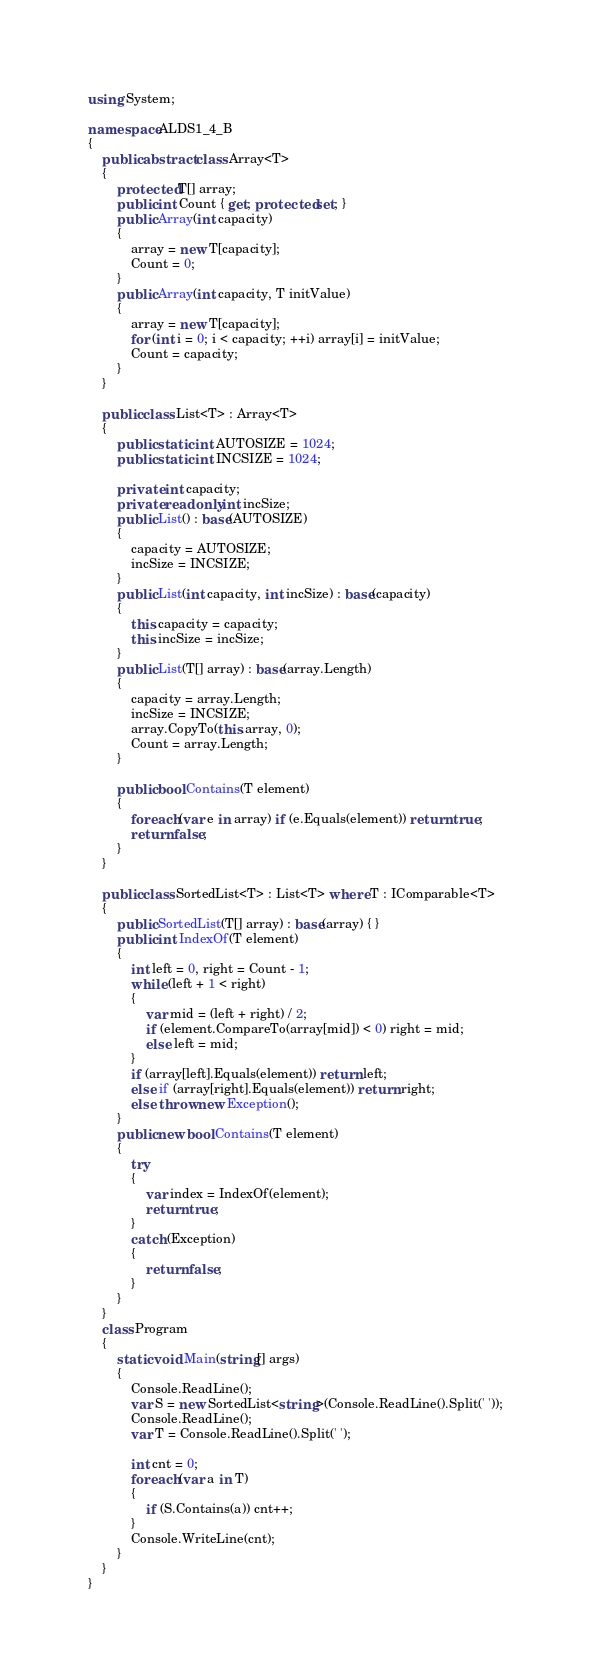Convert code to text. <code><loc_0><loc_0><loc_500><loc_500><_C#_>using System;

namespace ALDS1_4_B
{
    public abstract class Array<T>
    {
        protected T[] array;
        public int Count { get; protected set; }
        public Array(int capacity)
        {
            array = new T[capacity];
            Count = 0;
        }
        public Array(int capacity, T initValue)
        {
            array = new T[capacity];
            for (int i = 0; i < capacity; ++i) array[i] = initValue;
            Count = capacity;
        }
    }

    public class List<T> : Array<T>
    {
        public static int AUTOSIZE = 1024;
        public static int INCSIZE = 1024;

        private int capacity;
        private readonly int incSize;
        public List() : base(AUTOSIZE)
        {
            capacity = AUTOSIZE;
            incSize = INCSIZE;
        }
        public List(int capacity, int incSize) : base(capacity)
        {
            this.capacity = capacity;
            this.incSize = incSize;
        }
        public List(T[] array) : base(array.Length)
        {
            capacity = array.Length;
            incSize = INCSIZE;
            array.CopyTo(this.array, 0);
            Count = array.Length;
        }

        public bool Contains(T element)
        {
            foreach (var e in array) if (e.Equals(element)) return true;
            return false;
        }
    }

    public class SortedList<T> : List<T> where T : IComparable<T>
    {
        public SortedList(T[] array) : base(array) { }
        public int IndexOf(T element)
        {
            int left = 0, right = Count - 1;
            while (left + 1 < right)
            {
                var mid = (left + right) / 2;
                if (element.CompareTo(array[mid]) < 0) right = mid;
                else left = mid;
            }
            if (array[left].Equals(element)) return left;
            else if (array[right].Equals(element)) return right;
            else throw new Exception();
        }
        public new bool Contains(T element)
        {
            try
            {
                var index = IndexOf(element);
                return true;
            }
            catch (Exception)
            {
                return false;
            }
        }
    }
    class Program
    {
        static void Main(string[] args)
        {
            Console.ReadLine();
            var S = new SortedList<string>(Console.ReadLine().Split(' '));
            Console.ReadLine();
            var T = Console.ReadLine().Split(' ');

            int cnt = 0;
            foreach (var a in T)
            {
                if (S.Contains(a)) cnt++;
            }
            Console.WriteLine(cnt);
        }
    }
}</code> 